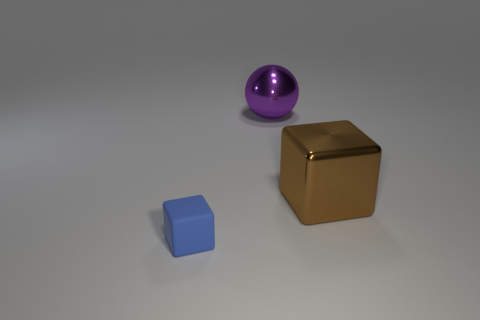Is there any other thing that is the same material as the tiny block?
Your response must be concise. No. What is the color of the sphere that is made of the same material as the brown thing?
Your answer should be very brief. Purple. Do the block that is to the left of the brown metallic object and the brown cube have the same size?
Ensure brevity in your answer.  No. There is a big object that is the same shape as the small object; what is its color?
Your answer should be very brief. Brown. What shape is the metallic object left of the cube that is on the right side of the small cube in front of the brown metal cube?
Keep it short and to the point. Sphere. Do the big brown object and the blue object have the same shape?
Your response must be concise. Yes. There is a thing that is in front of the big object in front of the purple shiny object; what shape is it?
Your response must be concise. Cube. Are there any brown objects?
Your answer should be compact. Yes. There is a cube right of the thing behind the shiny cube; what number of big metallic things are behind it?
Your answer should be very brief. 1. There is a matte thing; does it have the same shape as the big shiny object that is in front of the purple shiny ball?
Ensure brevity in your answer.  Yes. 